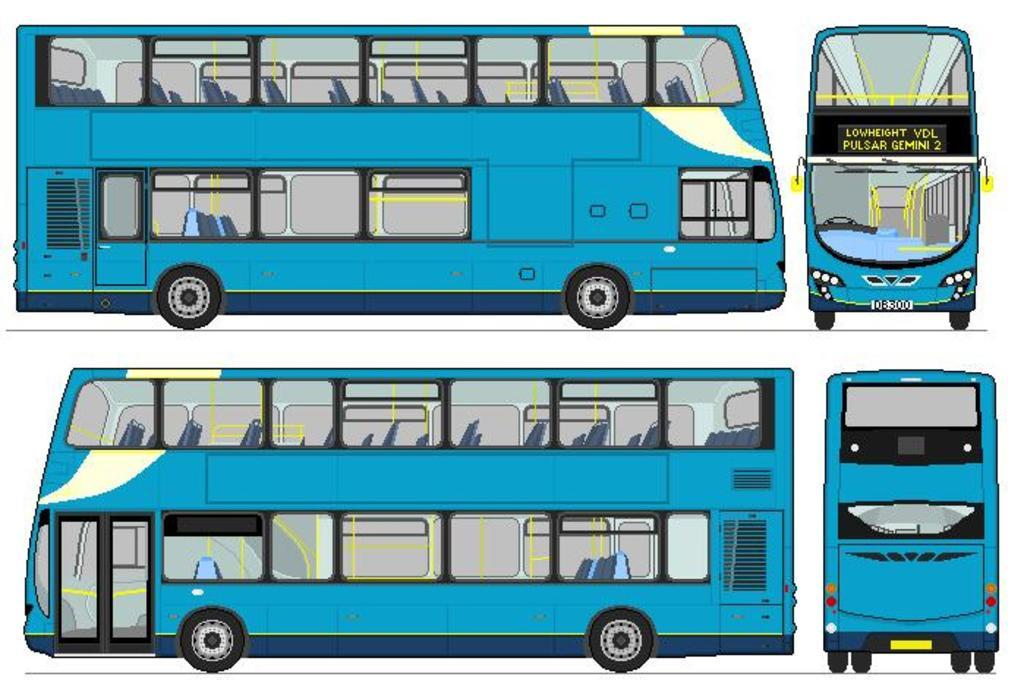What is the main subject of the image? The main subject of the image is an anime picture of a bus. How is the bus depicted in the image? The bus is depicted in different angles in the image. What is the income of the bus driver in the image? There is no information about the bus driver's income in the image, as it only shows an anime picture of a bus. Can you see a cart being pulled by the bus in the image? There is no cart present in the image; it only features an anime picture of a bus. 